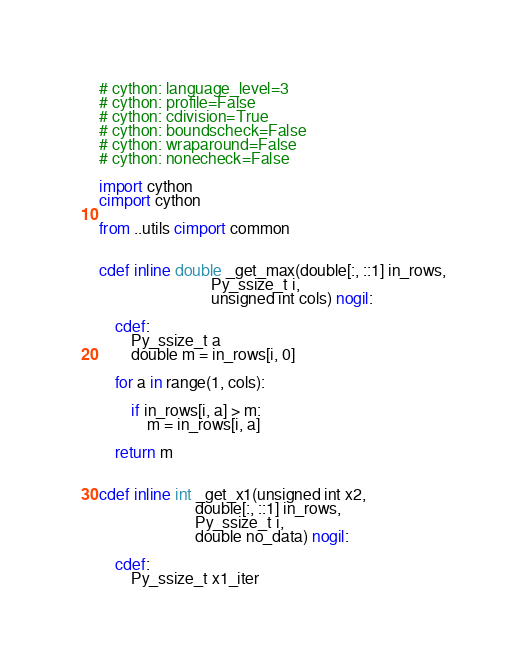<code> <loc_0><loc_0><loc_500><loc_500><_Cython_># cython: language_level=3
# cython: profile=False
# cython: cdivision=True
# cython: boundscheck=False
# cython: wraparound=False
# cython: nonecheck=False

import cython
cimport cython

from ..utils cimport common


cdef inline double _get_max(double[:, ::1] in_rows,
                            Py_ssize_t i,
                            unsigned int cols) nogil:

    cdef:
        Py_ssize_t a
        double m = in_rows[i, 0]

    for a in range(1, cols):

        if in_rows[i, a] > m:
            m = in_rows[i, a]

    return m


cdef inline int _get_x1(unsigned int x2,
                        double[:, ::1] in_rows,
                        Py_ssize_t i,
                        double no_data) nogil:

    cdef:
        Py_ssize_t x1_iter</code> 